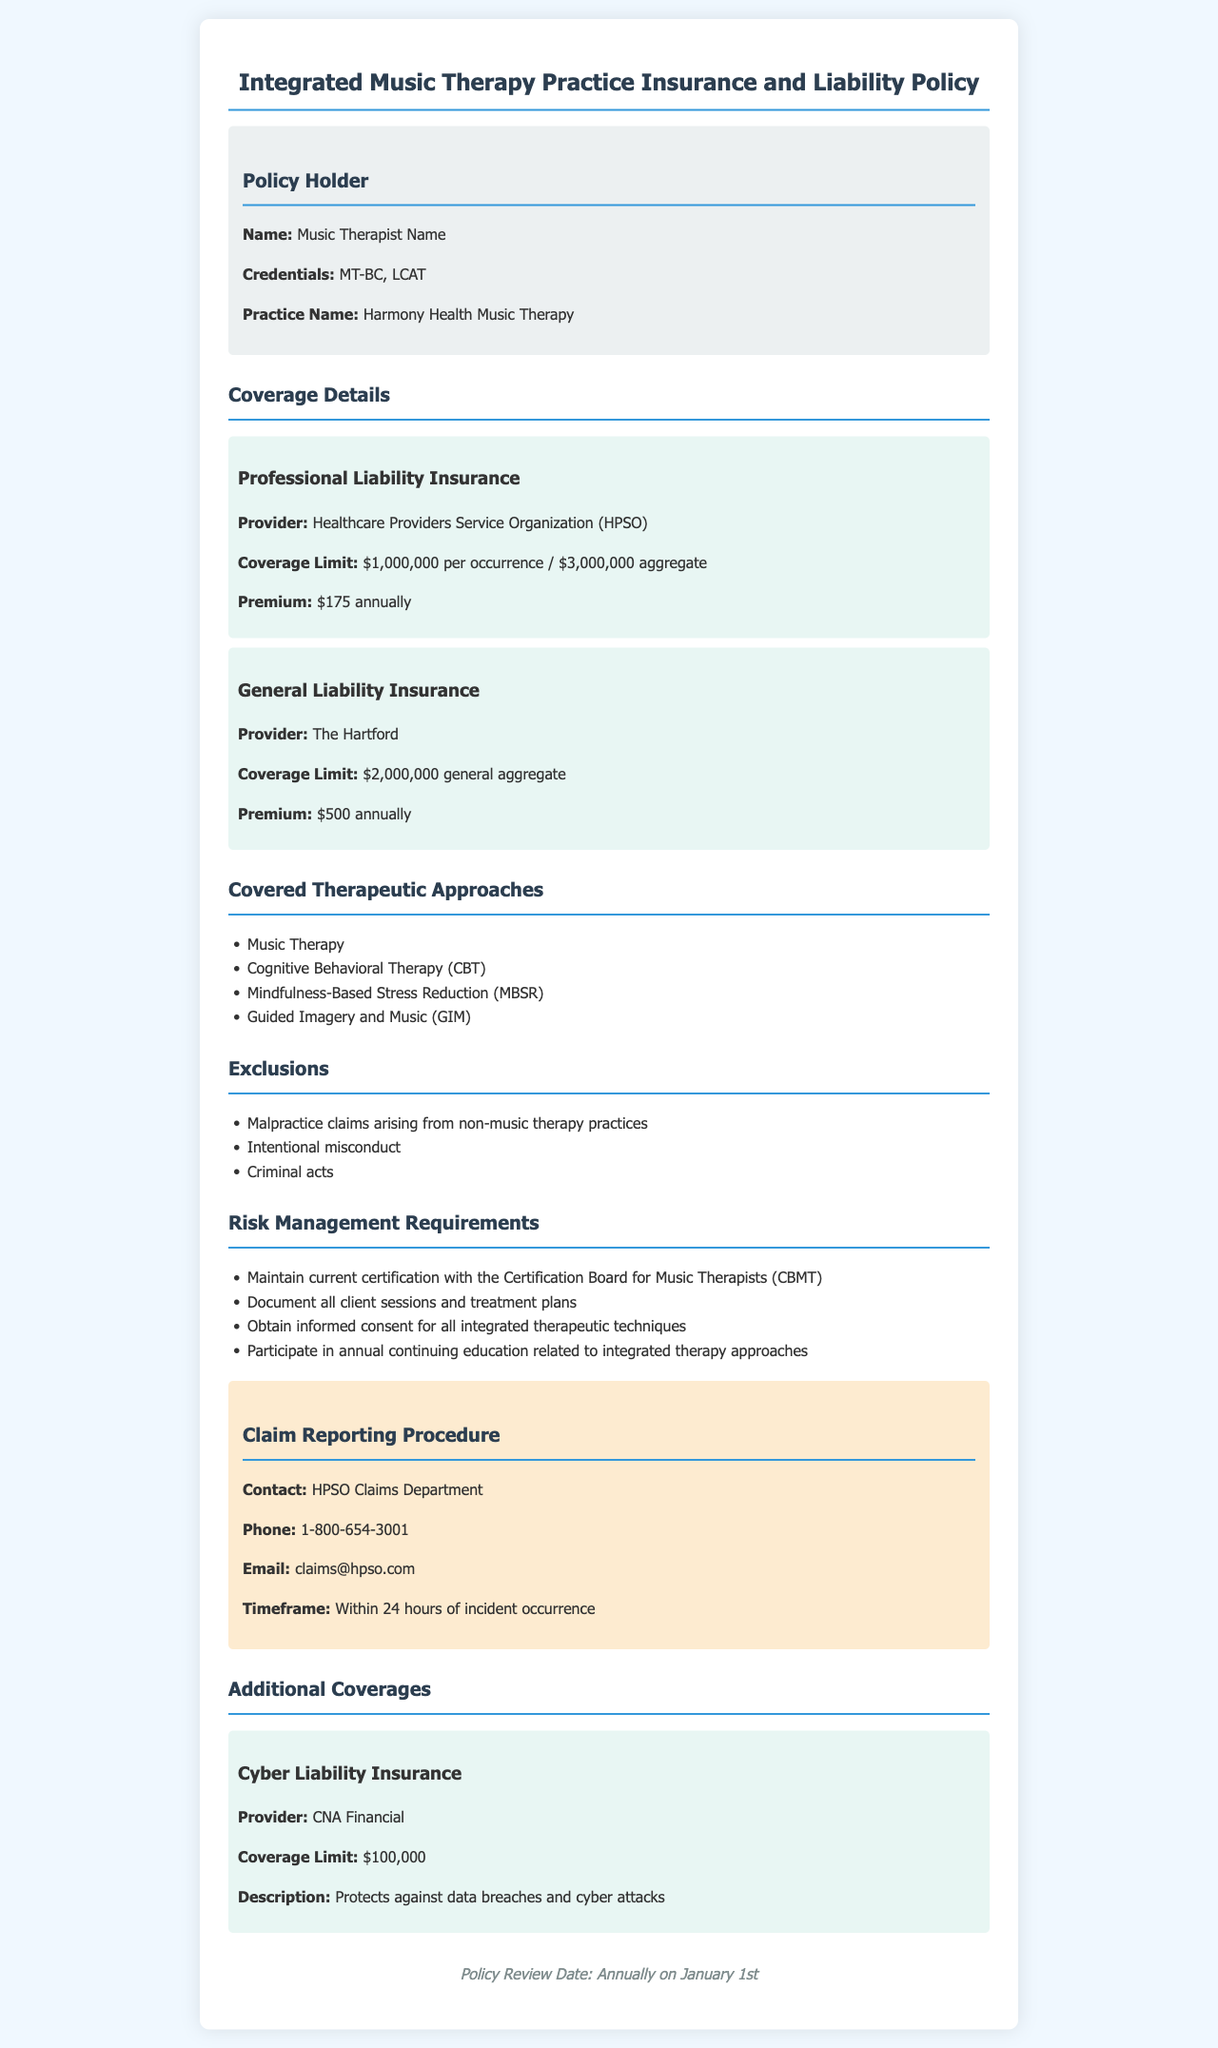What is the maximum coverage limit for professional liability insurance? The maximum coverage limit for professional liability insurance is specified as $1,000,000 per occurrence / $3,000,000 aggregate.
Answer: $1,000,000 per occurrence / $3,000,000 aggregate What type of therapy is included in the covered therapeutic approaches? Included therapeutic approaches are outlined in a list, which specifies "Music Therapy" as one of them.
Answer: Music Therapy Who provides the general liability insurance? The document states that general liability insurance is provided by a specific provider, which is "The Hartford".
Answer: The Hartford What is the premium for professional liability insurance? The premium for professional liability insurance is clearly stated in the coverage details.
Answer: $175 annually What is the timeframe to report a claim? The document mentions a specific timeframe for reporting claims, which is within 24 hours of incident occurrence.
Answer: Within 24 hours What must be obtained before using integrated therapeutic techniques? The risk management section specifies the necessity of obtaining something prior to using integrated techniques, which is informed consent.
Answer: Informed consent Which insurance protects against data breaches? The additional coverage section includes a type of insurance that specifically addresses data breaches, termed "Cyber Liability Insurance".
Answer: Cyber Liability Insurance What are the credentials of the policy holder? The document lists the credentials of the policy holder, which include "MT-BC, LCAT".
Answer: MT-BC, LCAT What is the claim contact's phone number? The claim reporting procedure section provides a contact number for the claims department, specified as 1-800-654-3001.
Answer: 1-800-654-3001 